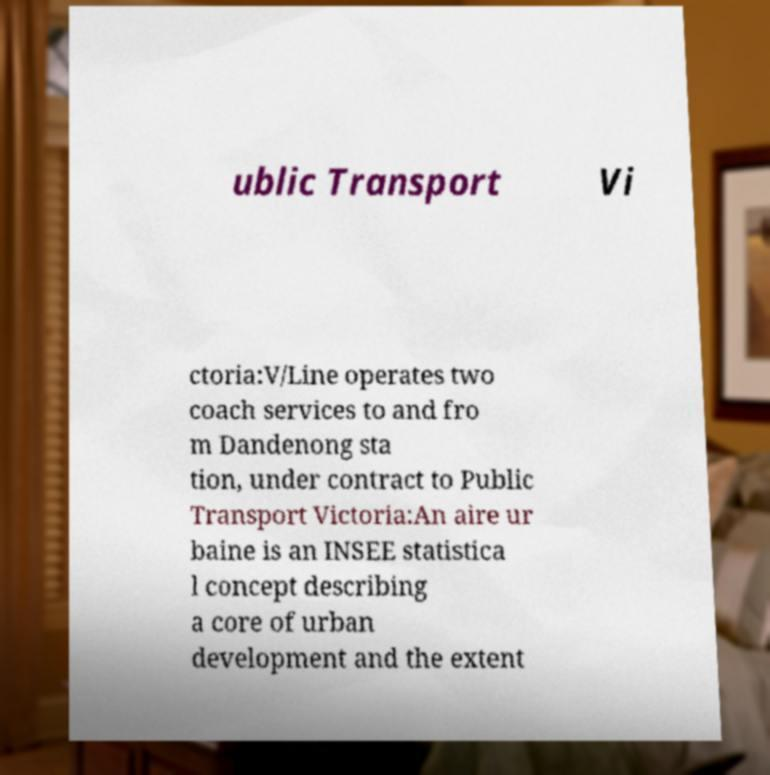Can you accurately transcribe the text from the provided image for me? ublic Transport Vi ctoria:V/Line operates two coach services to and fro m Dandenong sta tion, under contract to Public Transport Victoria:An aire ur baine is an INSEE statistica l concept describing a core of urban development and the extent 